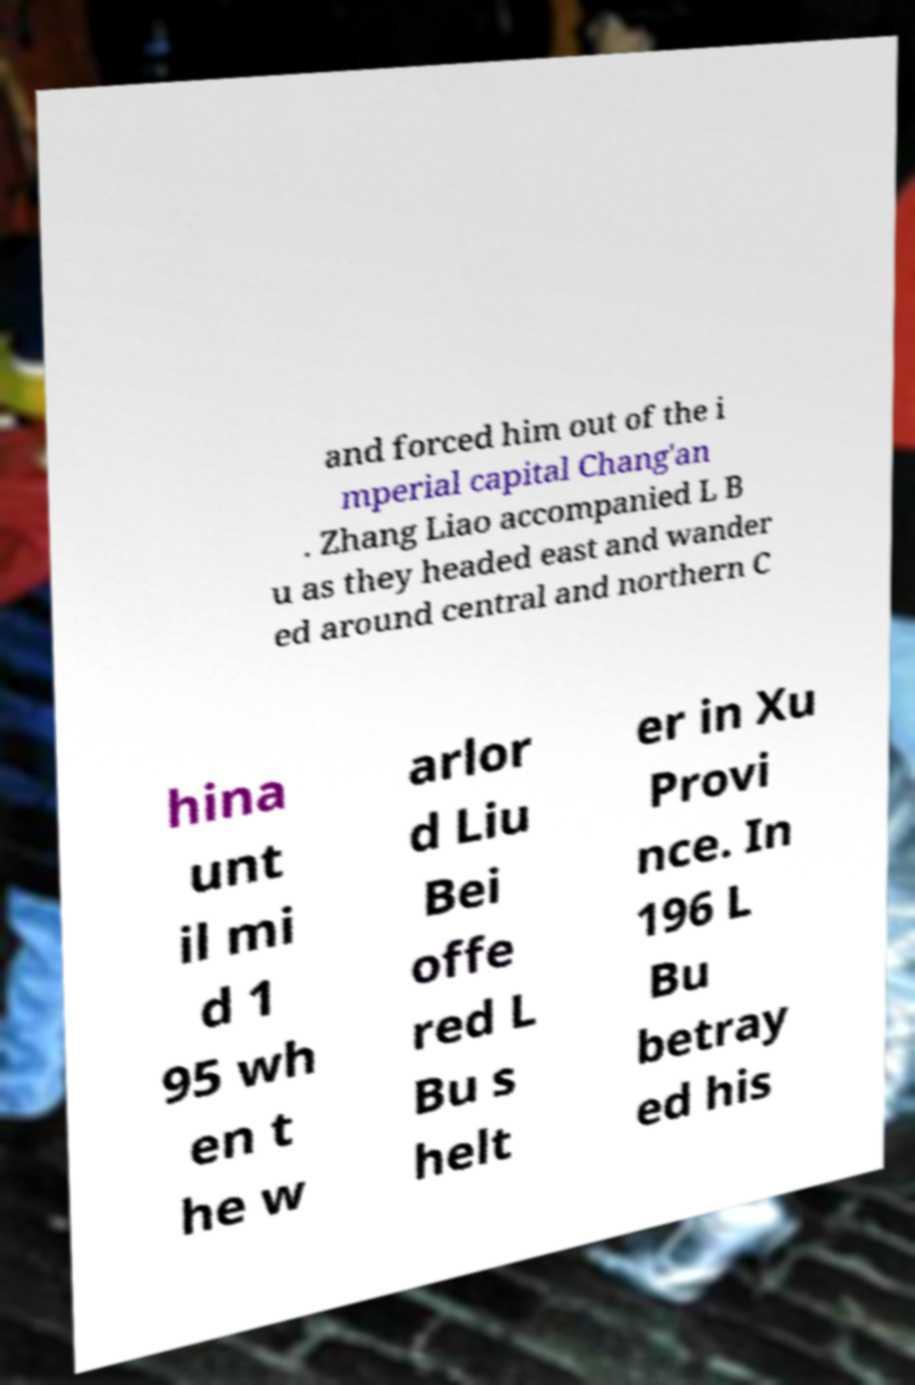There's text embedded in this image that I need extracted. Can you transcribe it verbatim? and forced him out of the i mperial capital Chang'an . Zhang Liao accompanied L B u as they headed east and wander ed around central and northern C hina unt il mi d 1 95 wh en t he w arlor d Liu Bei offe red L Bu s helt er in Xu Provi nce. In 196 L Bu betray ed his 